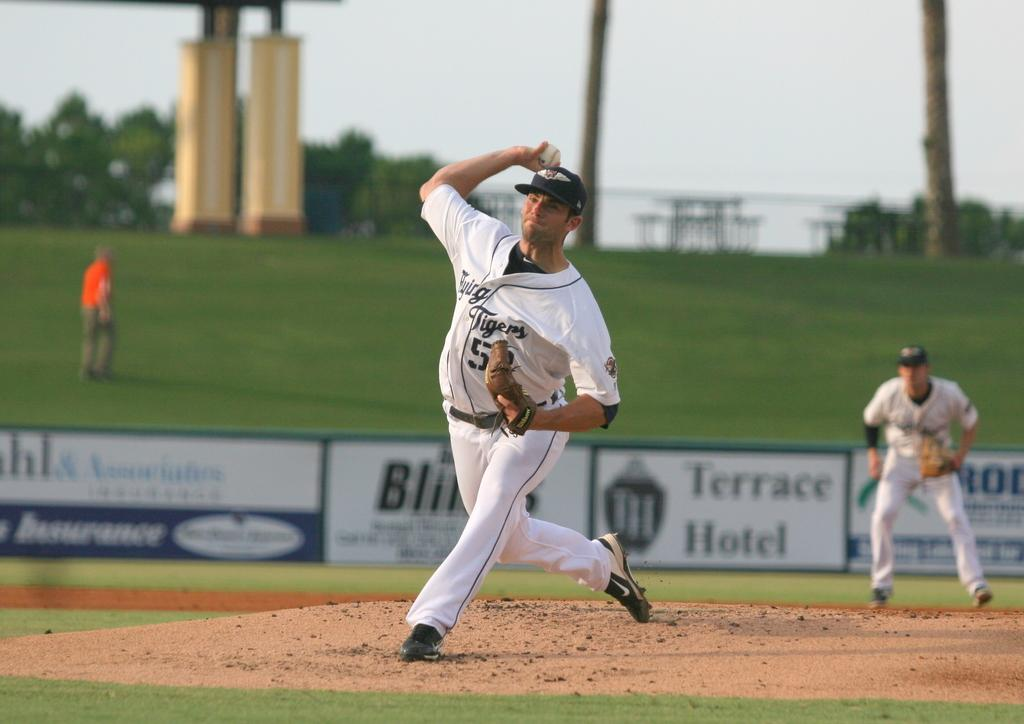Provide a one-sentence caption for the provided image. Professional baseball players near the back fence of the field with an advertisement for Terrace Hotel on it. 